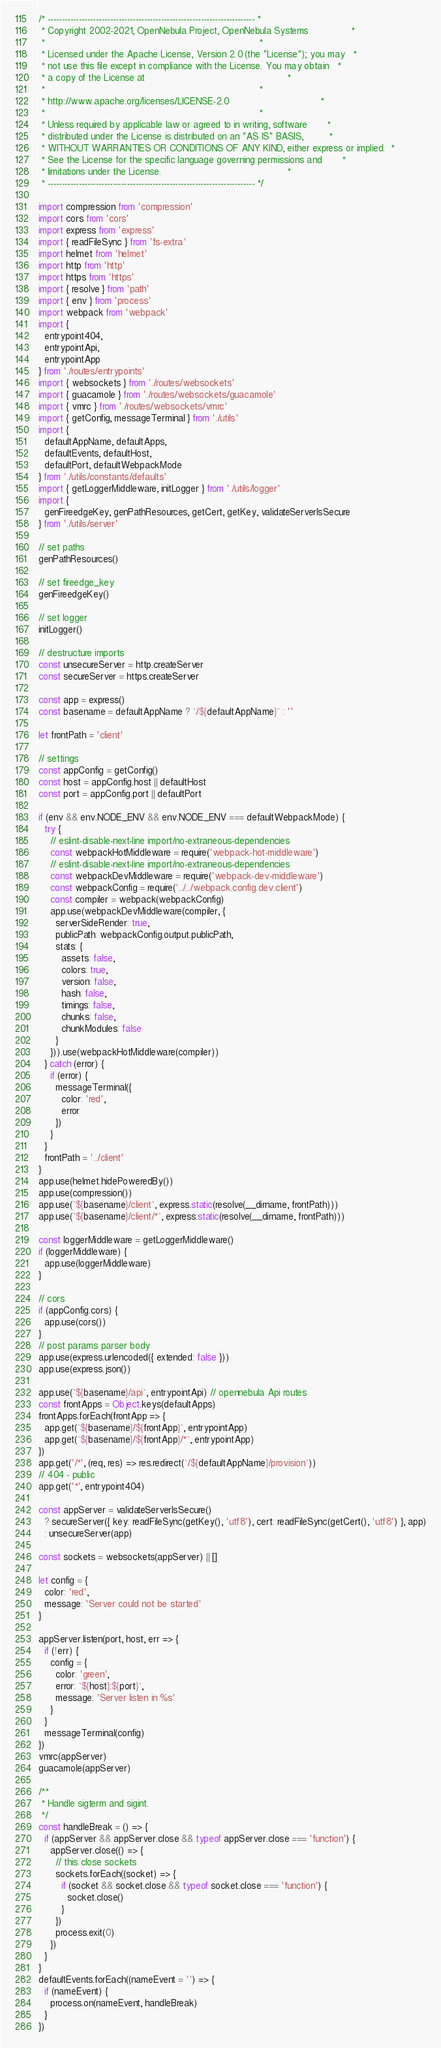Convert code to text. <code><loc_0><loc_0><loc_500><loc_500><_JavaScript_>/* ------------------------------------------------------------------------- *
 * Copyright 2002-2021, OpenNebula Project, OpenNebula Systems               *
 *                                                                           *
 * Licensed under the Apache License, Version 2.0 (the "License"); you may   *
 * not use this file except in compliance with the License. You may obtain   *
 * a copy of the License at                                                  *
 *                                                                           *
 * http://www.apache.org/licenses/LICENSE-2.0                                *
 *                                                                           *
 * Unless required by applicable law or agreed to in writing, software       *
 * distributed under the License is distributed on an "AS IS" BASIS,         *
 * WITHOUT WARRANTIES OR CONDITIONS OF ANY KIND, either express or implied.  *
 * See the License for the specific language governing permissions and       *
 * limitations under the License.                                            *
 * ------------------------------------------------------------------------- */

import compression from 'compression'
import cors from 'cors'
import express from 'express'
import { readFileSync } from 'fs-extra'
import helmet from 'helmet'
import http from 'http'
import https from 'https'
import { resolve } from 'path'
import { env } from 'process'
import webpack from 'webpack'
import {
  entrypoint404,
  entrypointApi,
  entrypointApp
} from './routes/entrypoints'
import { websockets } from './routes/websockets'
import { guacamole } from './routes/websockets/guacamole'
import { vmrc } from './routes/websockets/vmrc'
import { getConfig, messageTerminal } from './utils'
import {
  defaultAppName, defaultApps,
  defaultEvents, defaultHost,
  defaultPort, defaultWebpackMode
} from './utils/constants/defaults'
import { getLoggerMiddleware, initLogger } from './utils/logger'
import {
  genFireedgeKey, genPathResources, getCert, getKey, validateServerIsSecure
} from './utils/server'

// set paths
genPathResources()

// set fireedge_key
genFireedgeKey()

// set logger
initLogger()

// destructure imports
const unsecureServer = http.createServer
const secureServer = https.createServer

const app = express()
const basename = defaultAppName ? `/${defaultAppName}` : ''

let frontPath = 'client'

// settings
const appConfig = getConfig()
const host = appConfig.host || defaultHost
const port = appConfig.port || defaultPort

if (env && env.NODE_ENV && env.NODE_ENV === defaultWebpackMode) {
  try {
    // eslint-disable-next-line import/no-extraneous-dependencies
    const webpackHotMiddleware = require('webpack-hot-middleware')
    // eslint-disable-next-line import/no-extraneous-dependencies
    const webpackDevMiddleware = require('webpack-dev-middleware')
    const webpackConfig = require('../../webpack.config.dev.client')
    const compiler = webpack(webpackConfig)
    app.use(webpackDevMiddleware(compiler, {
      serverSideRender: true,
      publicPath: webpackConfig.output.publicPath,
      stats: {
        assets: false,
        colors: true,
        version: false,
        hash: false,
        timings: false,
        chunks: false,
        chunkModules: false
      }
    })).use(webpackHotMiddleware(compiler))
  } catch (error) {
    if (error) {
      messageTerminal({
        color: 'red',
        error
      })
    }
  }
  frontPath = '../client'
}
app.use(helmet.hidePoweredBy())
app.use(compression())
app.use(`${basename}/client`, express.static(resolve(__dirname, frontPath)))
app.use(`${basename}/client/*`, express.static(resolve(__dirname, frontPath)))

const loggerMiddleware = getLoggerMiddleware()
if (loggerMiddleware) {
  app.use(loggerMiddleware)
}

// cors
if (appConfig.cors) {
  app.use(cors())
}
// post params parser body
app.use(express.urlencoded({ extended: false }))
app.use(express.json())

app.use(`${basename}/api`, entrypointApi) // opennebula Api routes
const frontApps = Object.keys(defaultApps)
frontApps.forEach(frontApp => {
  app.get(`${basename}/${frontApp}`, entrypointApp)
  app.get(`${basename}/${frontApp}/*`, entrypointApp)
})
app.get('/*', (req, res) => res.redirect(`/${defaultAppName}/provision`))
// 404 - public
app.get('*', entrypoint404)

const appServer = validateServerIsSecure()
  ? secureServer({ key: readFileSync(getKey(), 'utf8'), cert: readFileSync(getCert(), 'utf8') }, app)
  : unsecureServer(app)

const sockets = websockets(appServer) || []

let config = {
  color: 'red',
  message: 'Server could not be started'
}

appServer.listen(port, host, err => {
  if (!err) {
    config = {
      color: 'green',
      error: `${host}:${port}`,
      message: 'Server listen in %s'
    }
  }
  messageTerminal(config)
})
vmrc(appServer)
guacamole(appServer)

/**
 * Handle sigterm and sigint.
 */
const handleBreak = () => {
  if (appServer && appServer.close && typeof appServer.close === 'function') {
    appServer.close(() => {
      // this close sockets
      sockets.forEach((socket) => {
        if (socket && socket.close && typeof socket.close === 'function') {
          socket.close()
        }
      })
      process.exit(0)
    })
  }
}
defaultEvents.forEach((nameEvent = '') => {
  if (nameEvent) {
    process.on(nameEvent, handleBreak)
  }
})
</code> 